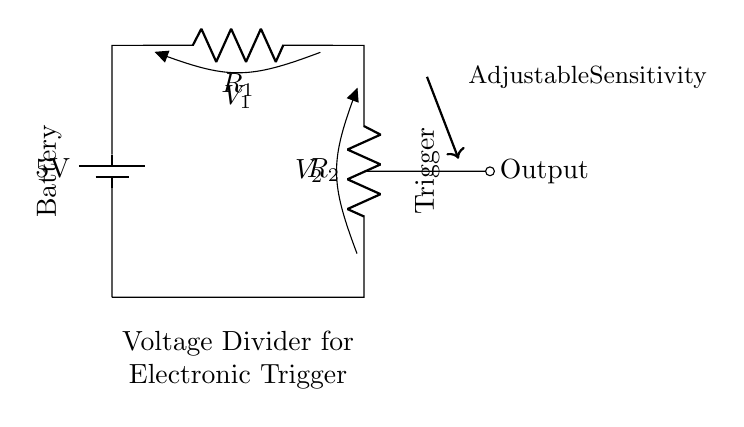What type of circuit is this? This circuit is a voltage divider, which consists of two resistors connected in series. It is used here to adjust the sensitivity of an electronic trigger.
Answer: Voltage divider What is the total voltage provided by the battery? The battery provides a voltage of 5 volts, which is indicated as the source in the circuit.
Answer: 5 volts What does the output represent in this circuit? The output represents the voltage across the second resistor, which is used to adjust the sensitivity of the electronic trigger based on the voltage divider formula.
Answer: Output voltage How many resistors are in the circuit? There are two resistors, labeled as R1 and R2, that make up the voltage divider in the circuit.
Answer: Two What is the relationship between R1 and R2 for adjusting voltage? The output voltage can be adjusted by changing the values of R1 and R2; the ratio of these resistances determines the voltage division according to the voltage divider rule.
Answer: Resistance ratio Which component controls the adjustable sensitivity? The adjustable sensitivity is controlled by the output voltage taken from the voltage divider formed by R1 and R2, which is influenced by the resistor values.
Answer: Output voltage 